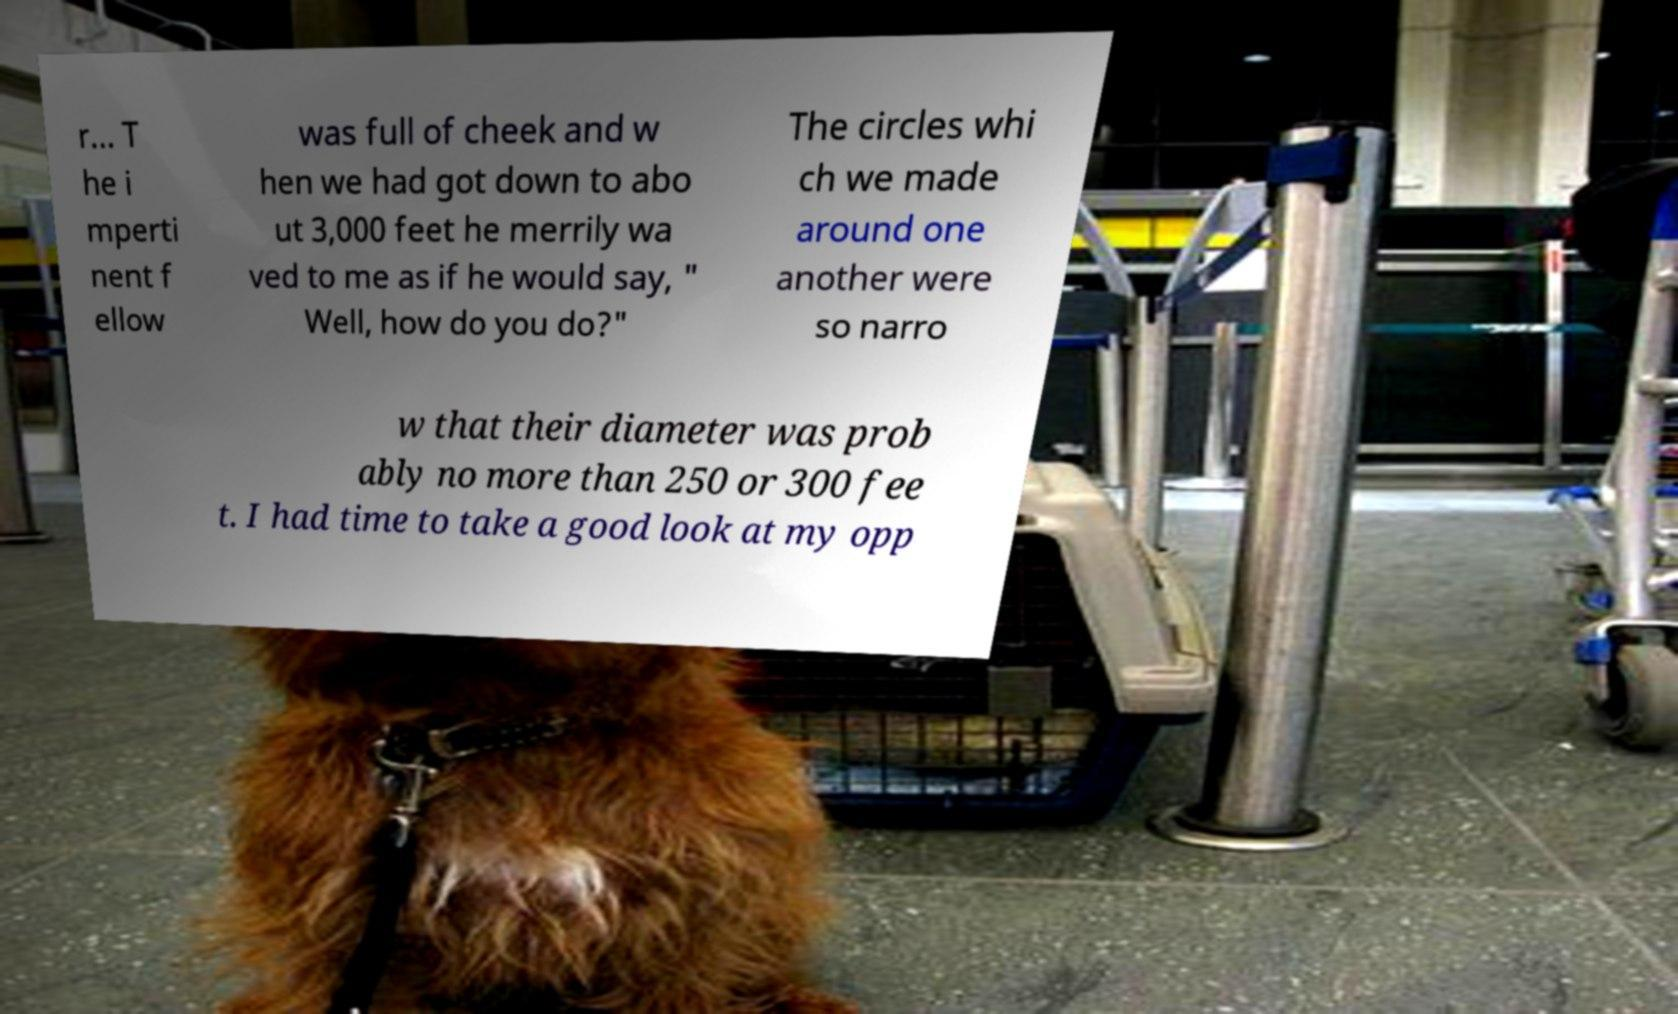Can you read and provide the text displayed in the image?This photo seems to have some interesting text. Can you extract and type it out for me? r... T he i mperti nent f ellow was full of cheek and w hen we had got down to abo ut 3,000 feet he merrily wa ved to me as if he would say, " Well, how do you do?" The circles whi ch we made around one another were so narro w that their diameter was prob ably no more than 250 or 300 fee t. I had time to take a good look at my opp 